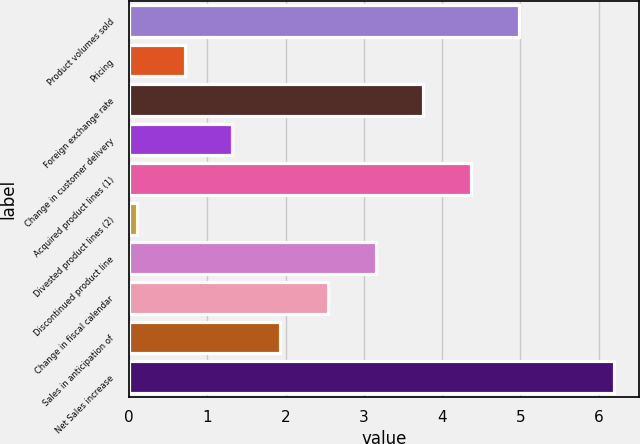Convert chart. <chart><loc_0><loc_0><loc_500><loc_500><bar_chart><fcel>Product volumes sold<fcel>Pricing<fcel>Foreign exchange rate<fcel>Change in customer delivery<fcel>Acquired product lines (1)<fcel>Divested product lines (2)<fcel>Discontinued product line<fcel>Change in fiscal calendar<fcel>Sales in anticipation of<fcel>Net Sales increase<nl><fcel>4.98<fcel>0.71<fcel>3.76<fcel>1.32<fcel>4.37<fcel>0.1<fcel>3.15<fcel>2.54<fcel>1.93<fcel>6.2<nl></chart> 